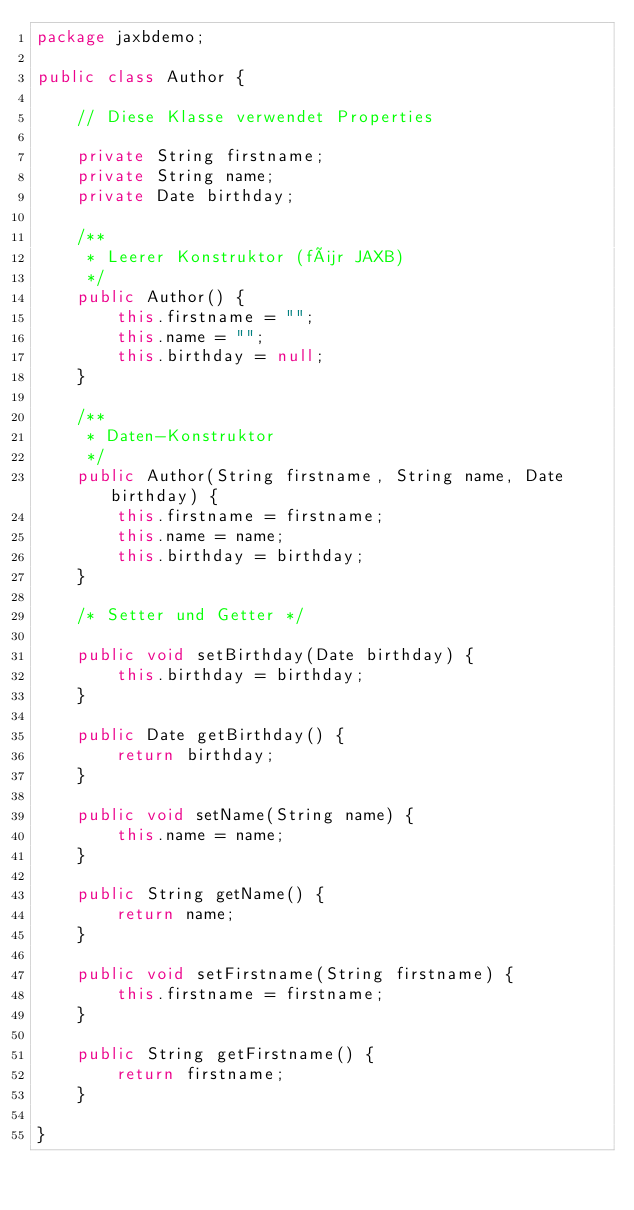<code> <loc_0><loc_0><loc_500><loc_500><_Java_>package jaxbdemo;

public class Author {

	// Diese Klasse verwendet Properties
	
	private String firstname;
	private String name;
	private Date birthday;
	
	/**
	 * Leerer Konstruktor (für JAXB)
	 */
	public Author() {
		this.firstname = "";
		this.name = "";
		this.birthday = null;
	}
	
	/**
	 * Daten-Konstruktor
	 */
	public Author(String firstname, String name, Date birthday) {
		this.firstname = firstname;
		this.name = name;
		this.birthday = birthday;
	}
	
	/* Setter und Getter */
	
	public void setBirthday(Date birthday) {
		this.birthday = birthday;
	}
	
	public Date getBirthday() {
		return birthday;
	}
	
	public void setName(String name) {
		this.name = name;
	}
	
	public String getName() {
		return name;
	}
	
	public void setFirstname(String firstname) {
		this.firstname = firstname;
	}
	
	public String getFirstname() {
		return firstname;
	}
	
}
</code> 